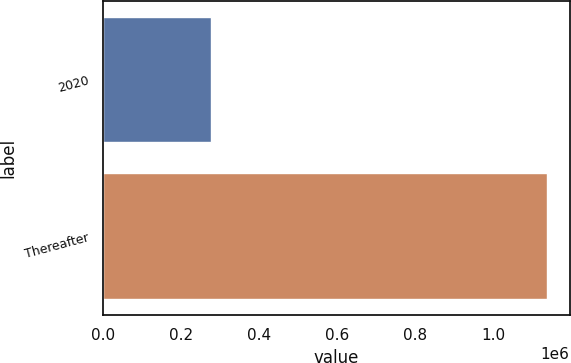<chart> <loc_0><loc_0><loc_500><loc_500><bar_chart><fcel>2020<fcel>Thereafter<nl><fcel>275000<fcel>1.14e+06<nl></chart> 